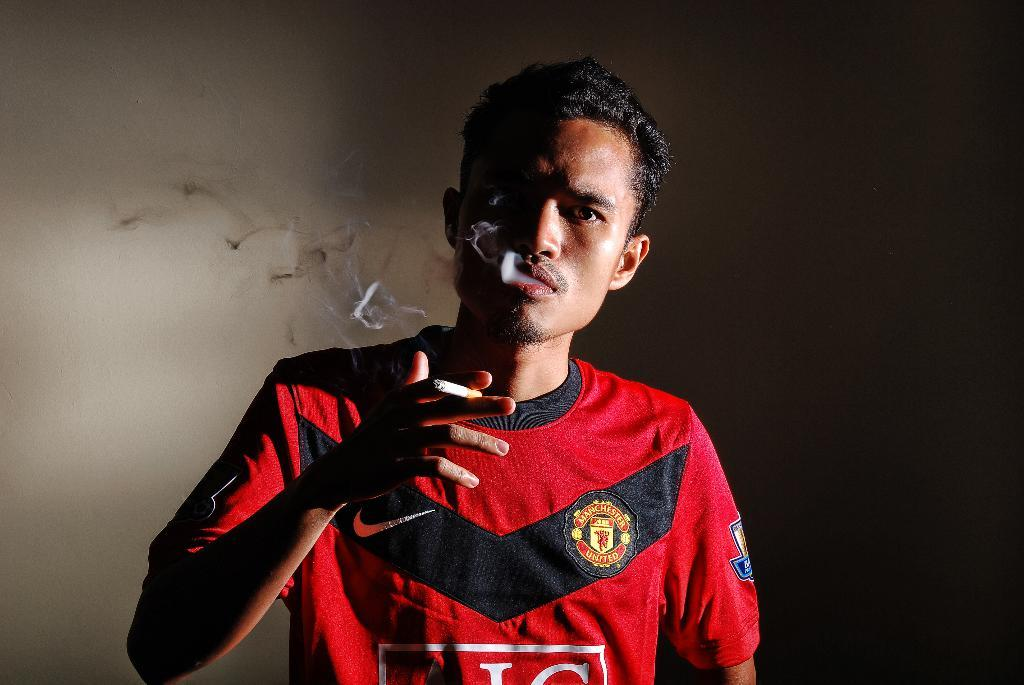Who is present in the image? There is a man in the image. What is the man holding in his hand? The man is holding a cigarette in his hand. What can be seen coming from the cigarette? There is smoke visible in the image. What is visible in the background of the image? There is a wall in the background of the image. What type of curtain can be seen moving in the image? There is no curtain present in the image, and therefore no movement of a curtain can be observed. 